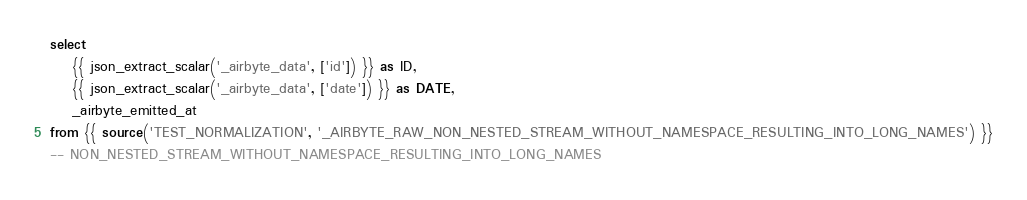<code> <loc_0><loc_0><loc_500><loc_500><_SQL_>select
    {{ json_extract_scalar('_airbyte_data', ['id']) }} as ID,
    {{ json_extract_scalar('_airbyte_data', ['date']) }} as DATE,
    _airbyte_emitted_at
from {{ source('TEST_NORMALIZATION', '_AIRBYTE_RAW_NON_NESTED_STREAM_WITHOUT_NAMESPACE_RESULTING_INTO_LONG_NAMES') }}
-- NON_NESTED_STREAM_WITHOUT_NAMESPACE_RESULTING_INTO_LONG_NAMES

</code> 